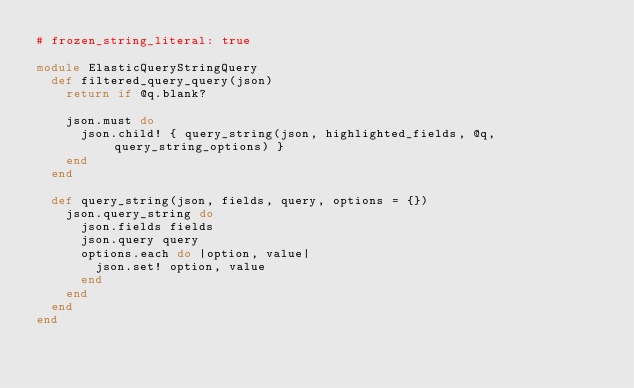<code> <loc_0><loc_0><loc_500><loc_500><_Ruby_># frozen_string_literal: true

module ElasticQueryStringQuery
  def filtered_query_query(json)
    return if @q.blank?

    json.must do
      json.child! { query_string(json, highlighted_fields, @q, query_string_options) }
    end
  end

  def query_string(json, fields, query, options = {})
    json.query_string do
      json.fields fields
      json.query query
      options.each do |option, value|
        json.set! option, value
      end
    end
  end
end
</code> 